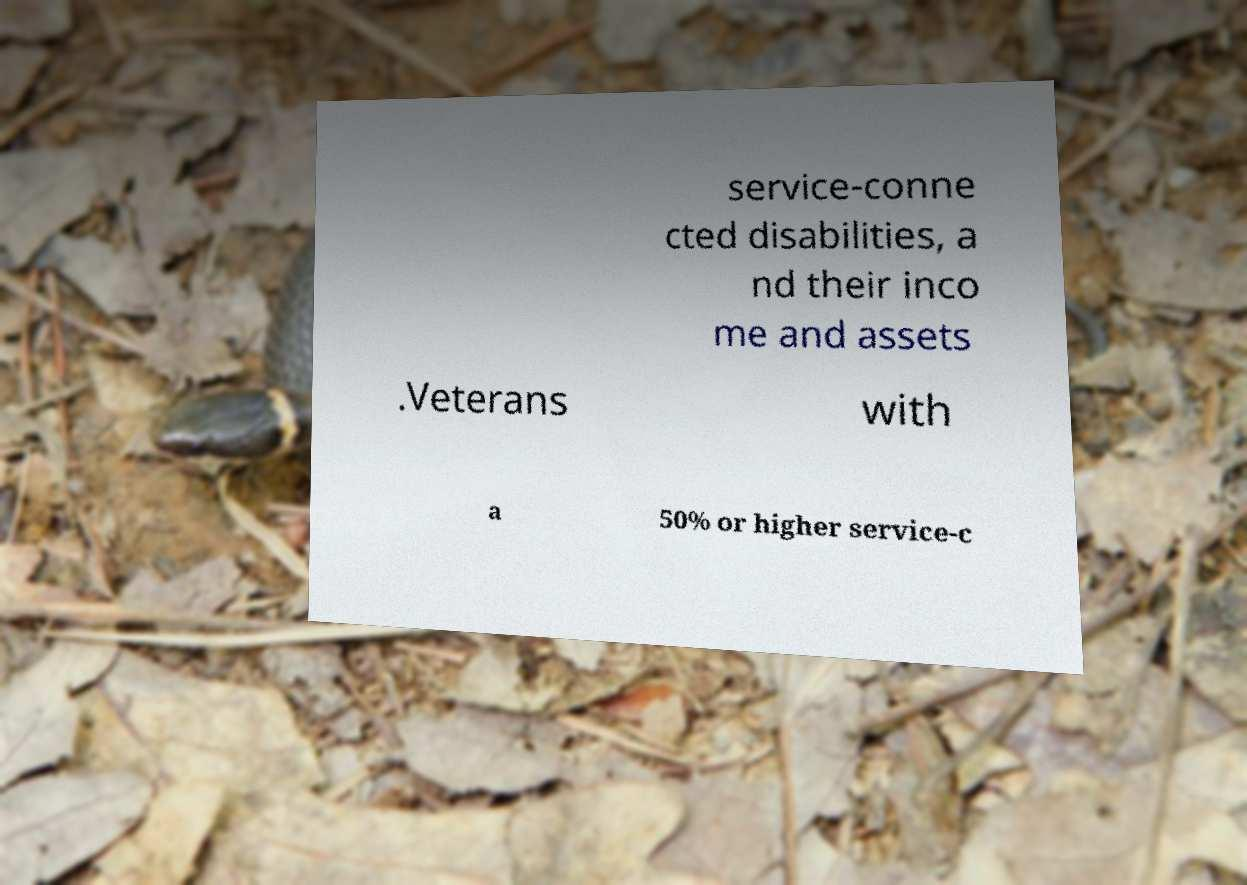Please identify and transcribe the text found in this image. service-conne cted disabilities, a nd their inco me and assets .Veterans with a 50% or higher service-c 